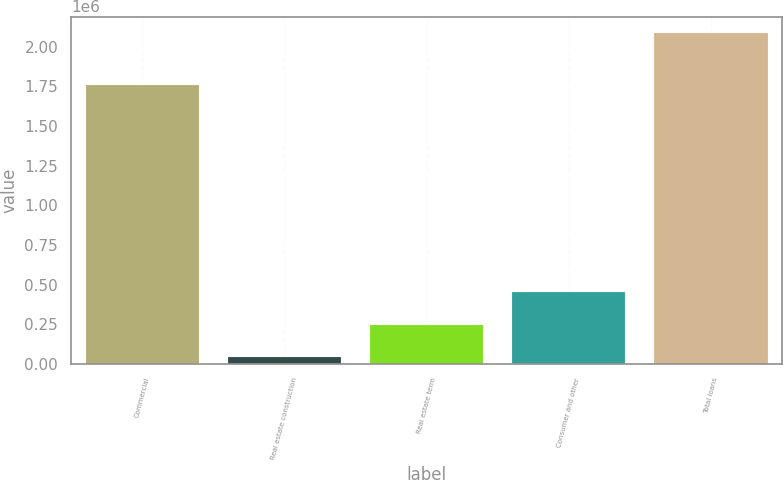Convert chart. <chart><loc_0><loc_0><loc_500><loc_500><bar_chart><fcel>Commercial<fcel>Real estate construction<fcel>Real estate term<fcel>Consumer and other<fcel>Total loans<nl><fcel>1.75618e+06<fcel>43178<fcel>247468<fcel>451758<fcel>2.08608e+06<nl></chart> 